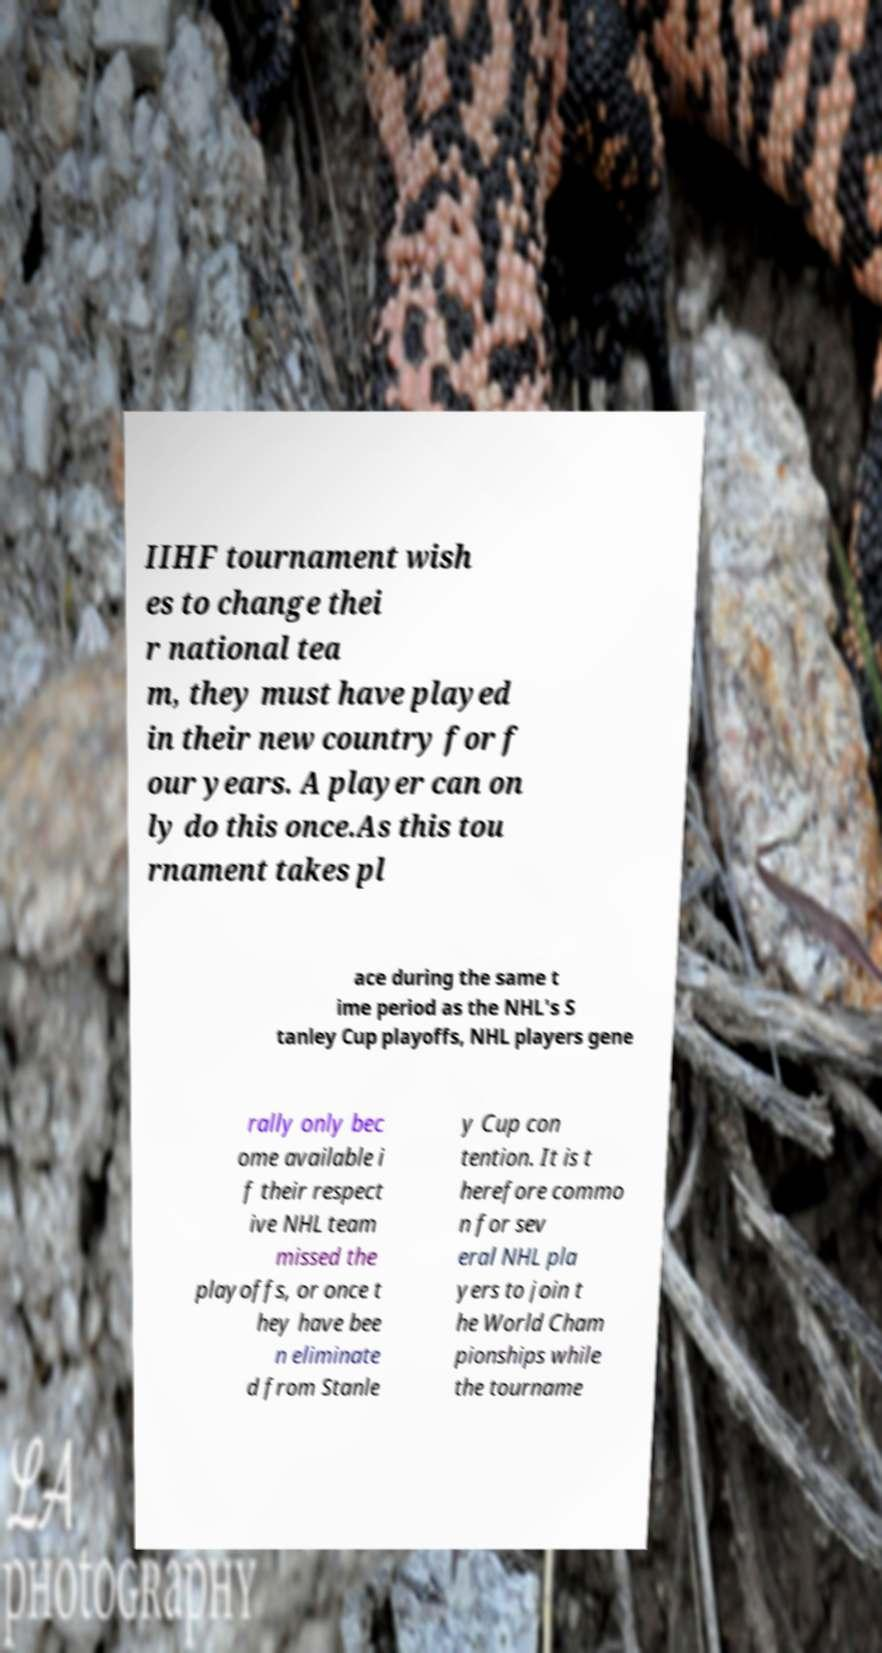Could you extract and type out the text from this image? IIHF tournament wish es to change thei r national tea m, they must have played in their new country for f our years. A player can on ly do this once.As this tou rnament takes pl ace during the same t ime period as the NHL's S tanley Cup playoffs, NHL players gene rally only bec ome available i f their respect ive NHL team missed the playoffs, or once t hey have bee n eliminate d from Stanle y Cup con tention. It is t herefore commo n for sev eral NHL pla yers to join t he World Cham pionships while the tourname 